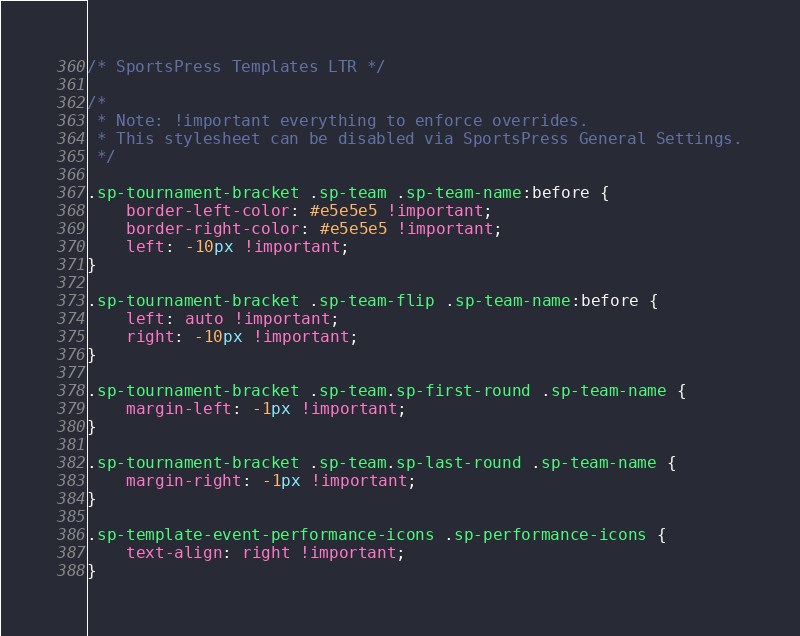Convert code to text. <code><loc_0><loc_0><loc_500><loc_500><_CSS_>/* SportsPress Templates LTR */

/*
 * Note: !important everything to enforce overrides.
 * This stylesheet can be disabled via SportsPress General Settings.
 */

.sp-tournament-bracket .sp-team .sp-team-name:before {
    border-left-color: #e5e5e5 !important;
    border-right-color: #e5e5e5 !important;
    left: -10px !important;
}

.sp-tournament-bracket .sp-team-flip .sp-team-name:before {
    left: auto !important;
    right: -10px !important;
}

.sp-tournament-bracket .sp-team.sp-first-round .sp-team-name {
    margin-left: -1px !important;
}

.sp-tournament-bracket .sp-team.sp-last-round .sp-team-name {
    margin-right: -1px !important;
}

.sp-template-event-performance-icons .sp-performance-icons {
    text-align: right !important;
}</code> 